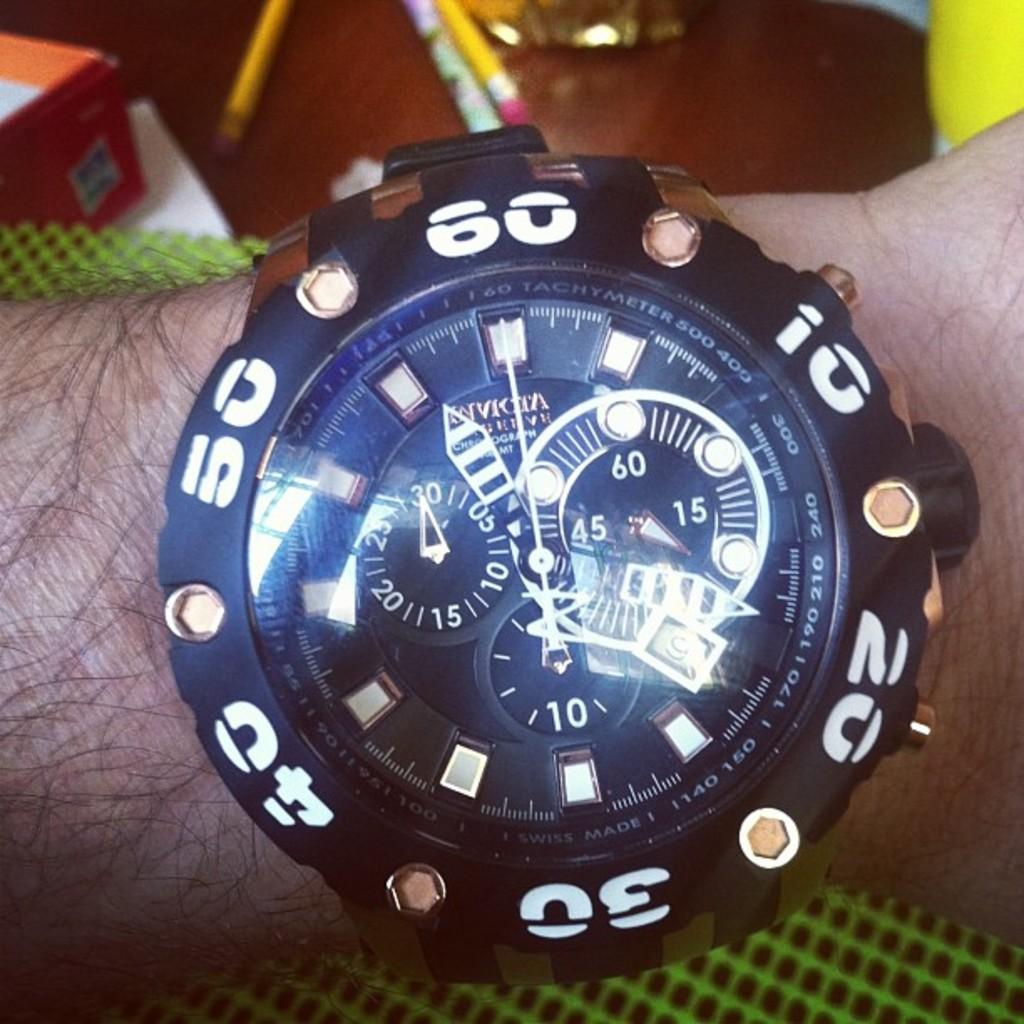<image>
Create a compact narrative representing the image presented. An Invicta branded watch in black with white numbers shown on someone's wrist. 